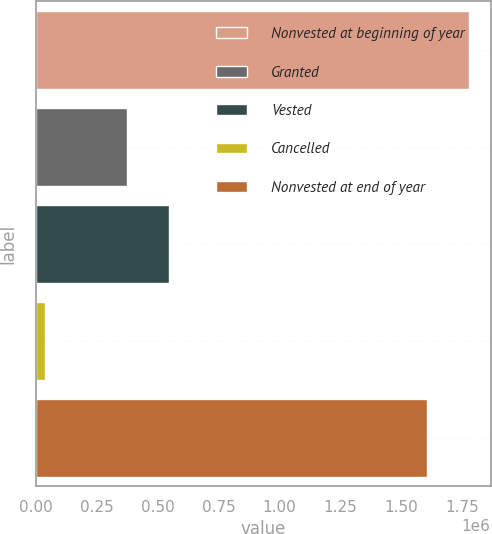Convert chart. <chart><loc_0><loc_0><loc_500><loc_500><bar_chart><fcel>Nonvested at beginning of year<fcel>Granted<fcel>Vested<fcel>Cancelled<fcel>Nonvested at end of year<nl><fcel>1.77887e+06<fcel>374425<fcel>547251<fcel>37573<fcel>1.60605e+06<nl></chart> 